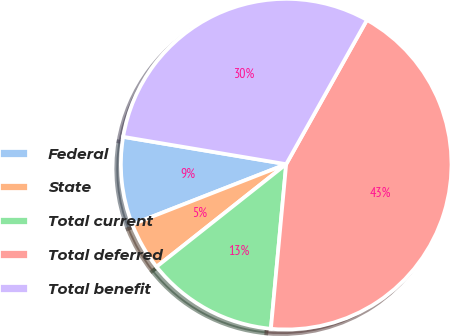Convert chart to OTSL. <chart><loc_0><loc_0><loc_500><loc_500><pie_chart><fcel>Federal<fcel>State<fcel>Total current<fcel>Total deferred<fcel>Total benefit<nl><fcel>8.58%<fcel>4.72%<fcel>12.87%<fcel>43.35%<fcel>30.48%<nl></chart> 